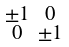<formula> <loc_0><loc_0><loc_500><loc_500>\begin{smallmatrix} \pm 1 & 0 \\ 0 & \pm 1 \end{smallmatrix}</formula> 